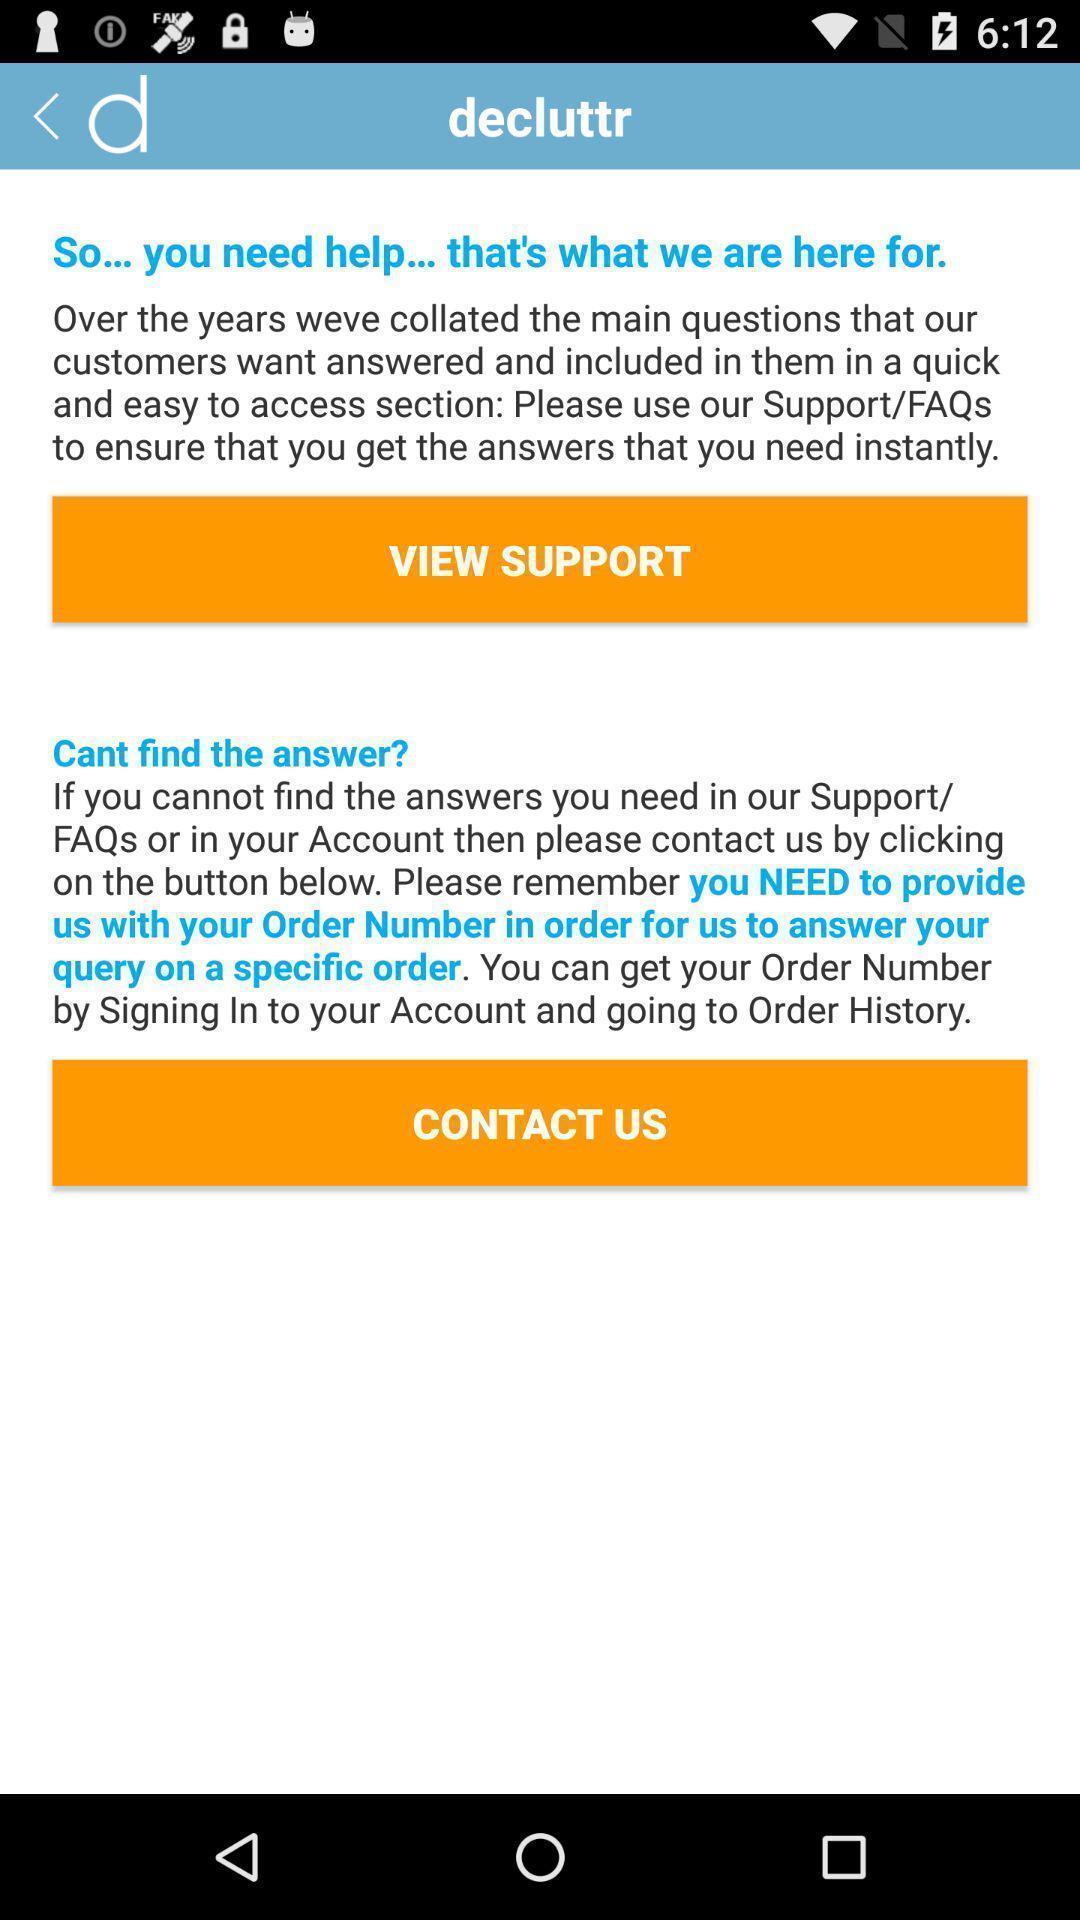Explain what's happening in this screen capture. Support and contact page of bar code scanning app. 